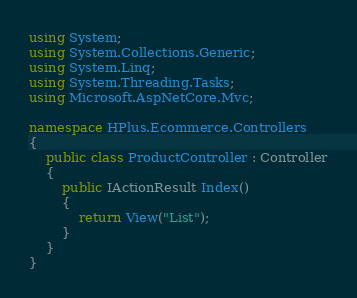Convert code to text. <code><loc_0><loc_0><loc_500><loc_500><_C#_>using System;
using System.Collections.Generic;
using System.Linq;
using System.Threading.Tasks;
using Microsoft.AspNetCore.Mvc;

namespace HPlus.Ecommerce.Controllers
{
    public class ProductController : Controller
    {
        public IActionResult Index()
        {
            return View("List");
        }
    }
}</code> 